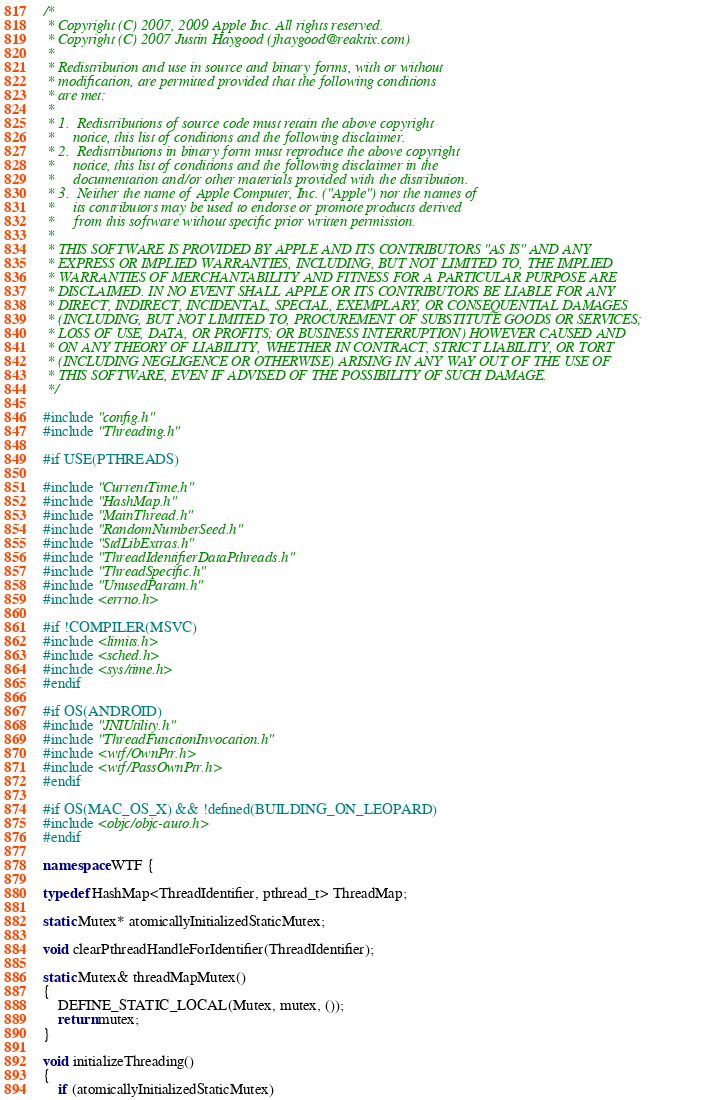Convert code to text. <code><loc_0><loc_0><loc_500><loc_500><_C++_>/*
 * Copyright (C) 2007, 2009 Apple Inc. All rights reserved.
 * Copyright (C) 2007 Justin Haygood (jhaygood@reaktix.com)
 *
 * Redistribution and use in source and binary forms, with or without
 * modification, are permitted provided that the following conditions
 * are met:
 *
 * 1.  Redistributions of source code must retain the above copyright
 *     notice, this list of conditions and the following disclaimer. 
 * 2.  Redistributions in binary form must reproduce the above copyright
 *     notice, this list of conditions and the following disclaimer in the
 *     documentation and/or other materials provided with the distribution. 
 * 3.  Neither the name of Apple Computer, Inc. ("Apple") nor the names of
 *     its contributors may be used to endorse or promote products derived
 *     from this software without specific prior written permission. 
 *
 * THIS SOFTWARE IS PROVIDED BY APPLE AND ITS CONTRIBUTORS "AS IS" AND ANY
 * EXPRESS OR IMPLIED WARRANTIES, INCLUDING, BUT NOT LIMITED TO, THE IMPLIED
 * WARRANTIES OF MERCHANTABILITY AND FITNESS FOR A PARTICULAR PURPOSE ARE
 * DISCLAIMED. IN NO EVENT SHALL APPLE OR ITS CONTRIBUTORS BE LIABLE FOR ANY
 * DIRECT, INDIRECT, INCIDENTAL, SPECIAL, EXEMPLARY, OR CONSEQUENTIAL DAMAGES
 * (INCLUDING, BUT NOT LIMITED TO, PROCUREMENT OF SUBSTITUTE GOODS OR SERVICES;
 * LOSS OF USE, DATA, OR PROFITS; OR BUSINESS INTERRUPTION) HOWEVER CAUSED AND
 * ON ANY THEORY OF LIABILITY, WHETHER IN CONTRACT, STRICT LIABILITY, OR TORT
 * (INCLUDING NEGLIGENCE OR OTHERWISE) ARISING IN ANY WAY OUT OF THE USE OF
 * THIS SOFTWARE, EVEN IF ADVISED OF THE POSSIBILITY OF SUCH DAMAGE.
 */

#include "config.h"
#include "Threading.h"

#if USE(PTHREADS)

#include "CurrentTime.h"
#include "HashMap.h"
#include "MainThread.h"
#include "RandomNumberSeed.h"
#include "StdLibExtras.h"
#include "ThreadIdentifierDataPthreads.h"
#include "ThreadSpecific.h"
#include "UnusedParam.h"
#include <errno.h>

#if !COMPILER(MSVC)
#include <limits.h>
#include <sched.h>
#include <sys/time.h>
#endif

#if OS(ANDROID)
#include "JNIUtility.h"
#include "ThreadFunctionInvocation.h"
#include <wtf/OwnPtr.h>
#include <wtf/PassOwnPtr.h>
#endif

#if OS(MAC_OS_X) && !defined(BUILDING_ON_LEOPARD)
#include <objc/objc-auto.h>
#endif

namespace WTF {

typedef HashMap<ThreadIdentifier, pthread_t> ThreadMap;

static Mutex* atomicallyInitializedStaticMutex;

void clearPthreadHandleForIdentifier(ThreadIdentifier);

static Mutex& threadMapMutex()
{
    DEFINE_STATIC_LOCAL(Mutex, mutex, ());
    return mutex;
}

void initializeThreading()
{
    if (atomicallyInitializedStaticMutex)</code> 